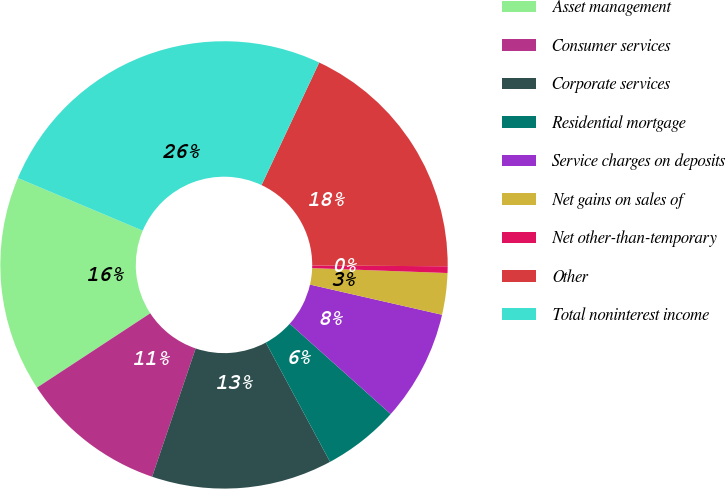<chart> <loc_0><loc_0><loc_500><loc_500><pie_chart><fcel>Asset management<fcel>Consumer services<fcel>Corporate services<fcel>Residential mortgage<fcel>Service charges on deposits<fcel>Net gains on sales of<fcel>Net other-than-temporary<fcel>Other<fcel>Total noninterest income<nl><fcel>15.59%<fcel>10.55%<fcel>13.07%<fcel>5.52%<fcel>8.04%<fcel>3.0%<fcel>0.48%<fcel>18.1%<fcel>25.65%<nl></chart> 